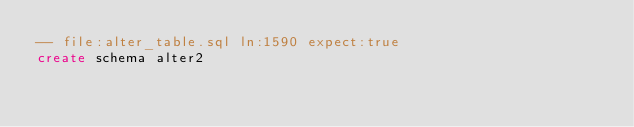<code> <loc_0><loc_0><loc_500><loc_500><_SQL_>-- file:alter_table.sql ln:1590 expect:true
create schema alter2
</code> 